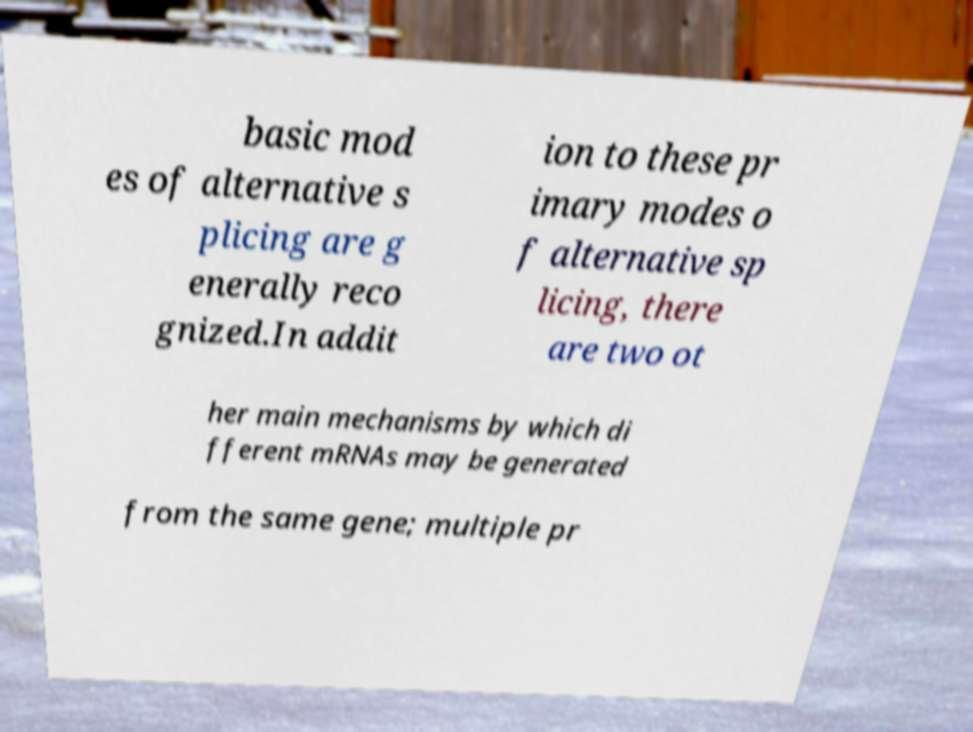Can you accurately transcribe the text from the provided image for me? basic mod es of alternative s plicing are g enerally reco gnized.In addit ion to these pr imary modes o f alternative sp licing, there are two ot her main mechanisms by which di fferent mRNAs may be generated from the same gene; multiple pr 